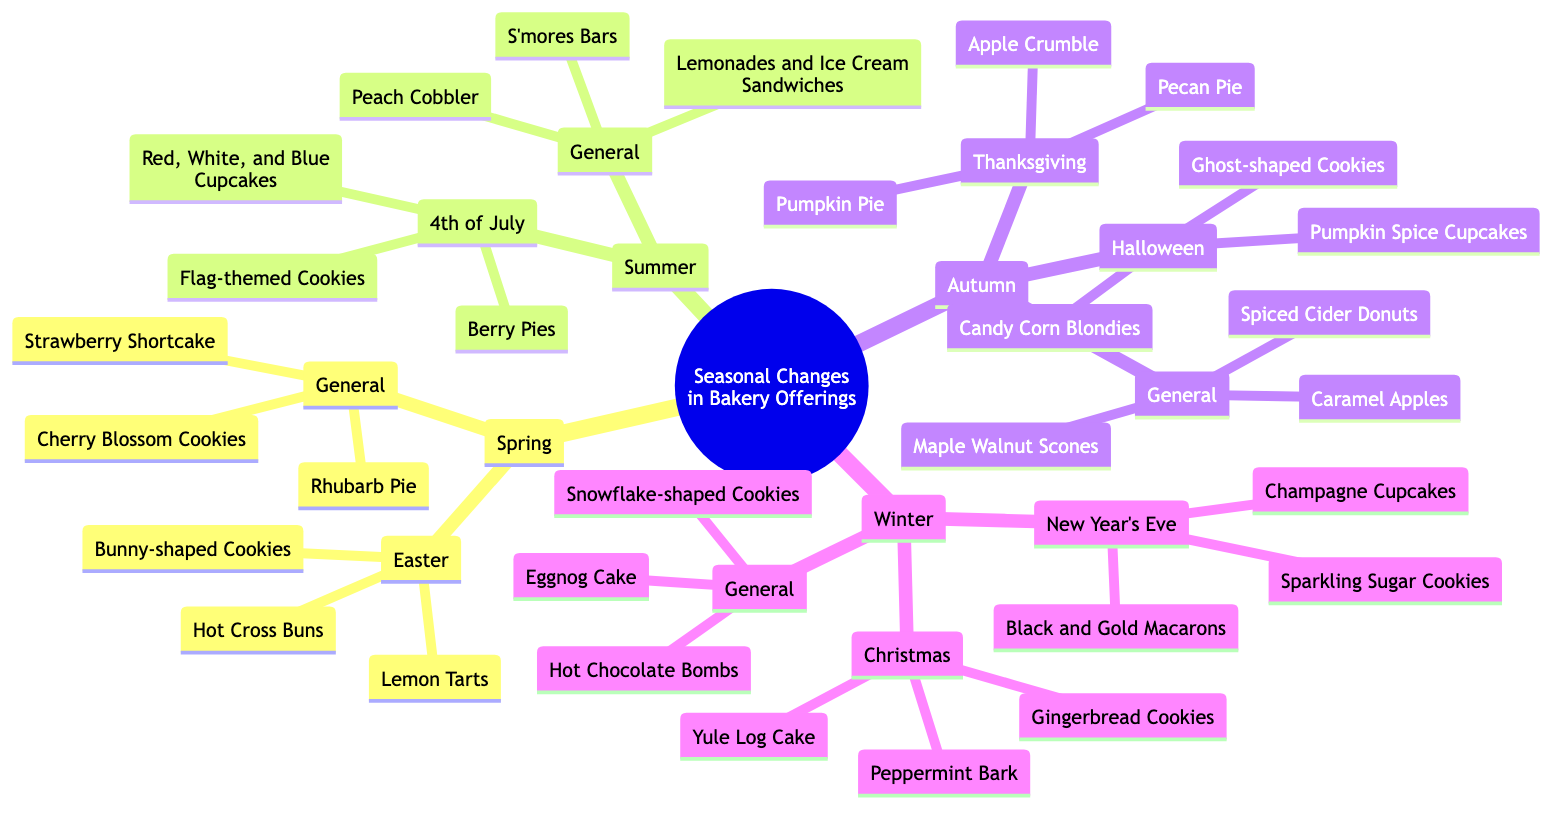What treats are offered during Easter? According to the diagram, the treats specifically offered during Easter under Spring are Hot Cross Buns, Bunny-shaped Cookies, and Lemon Tarts.
Answer: Hot Cross Buns, Bunny-shaped Cookies, Lemon Tarts How many holiday categories are in Autumn? Looking at the Autumn section, there are two holiday categories: Halloween and Thanksgiving. Thus, the total count is two.
Answer: 2 What is a general offering in Winter? In the Winter section, one of the general offerings mentioned is Hot Chocolate Bombs. This reflects a common dessert available regardless of specific holidays.
Answer: Hot Chocolate Bombs Which holiday treats are common in Summer? The specific treats for the 4th of July in Summer include Red, White, and Blue Cupcakes, Berry Pies, and Flag-themed Cookies, showing the thematic offerings of that season.
Answer: Red, White, and Blue Cupcakes, Berry Pies, Flag-themed Cookies What type of cookies are found in the Autumn general section? The Autumn general section lists Spiced Cider Donuts, Maple Walnut Scones, and Caramel Apples, which provide a range of autumnal flavors, including cookies.
Answer: Spiced Cider Donuts Which season features Pumpkin Pie? Checking the diagram, Pumpkin Pie is featured under the Thanksgiving category, which is part of the Autumn season. This establishes the seasonal connection of this treat.
Answer: Autumn What is the relationship between Christmas and Winter? The diagram categorizes Christmas treats, such as Gingerbread Cookies, Yule Log Cake, and Peppermint Bark, under the Winter season, clearly establishing that Christmas is a subset of Winter offerings.
Answer: Christmas is a subset of Winter How many general offerings are there in Spring? Under the Spring section, the General category contains three offerings: Strawberry Shortcake, Rhubarb Pie, and Cherry Blossom Cookies, leading to the conclusion that there are three general offerings.
Answer: 3 